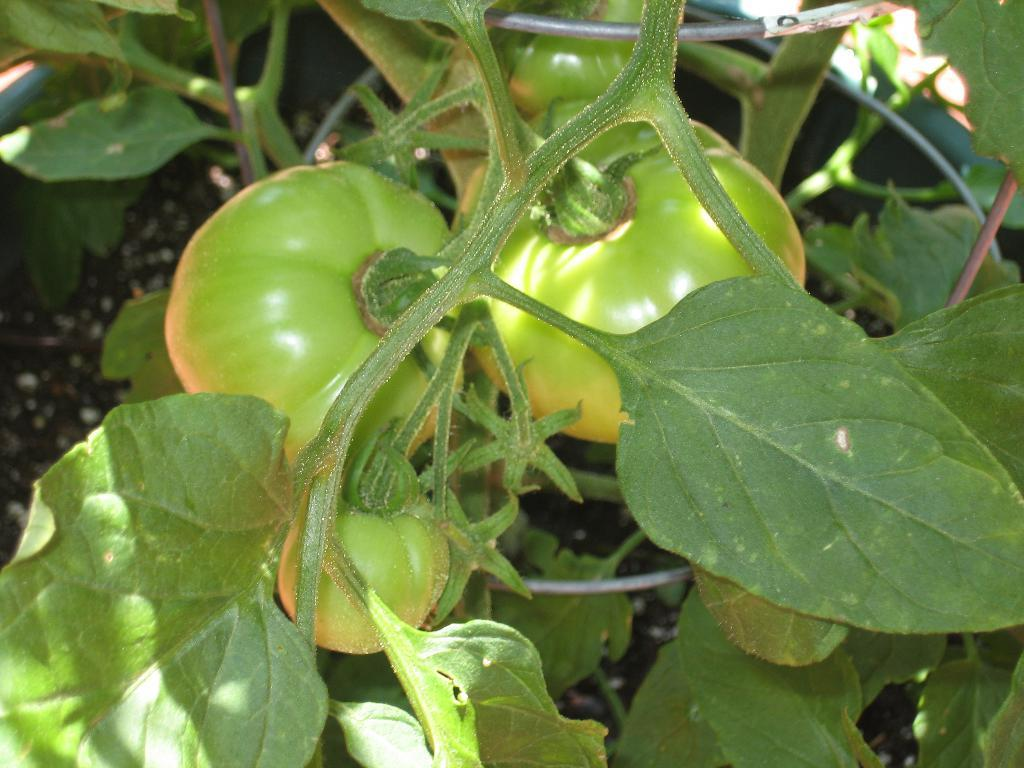What type of plants are in the image? There are tomato plants in the image. What is the color of the tomatoes on the plants? The tomatoes on the plants are green. What type of quill is being used to write on the crib in the image? There is no quill or crib present in the image; it features tomato plants with green tomatoes. 